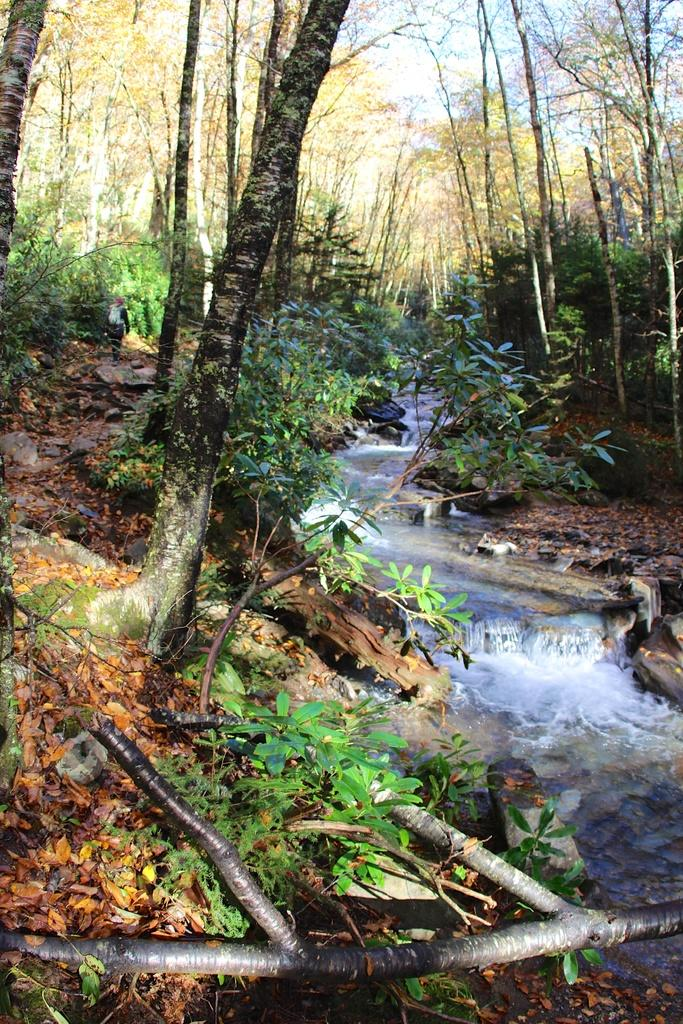What type of vegetation can be seen in the image? There are trees and plants in the image. What is the primary feature of the image? Water is flowing in the image. Where is the locket hidden in the image? There is no locket present in the image. What type of parcel is being delivered in the image? There is no parcel being delivered in the image. 